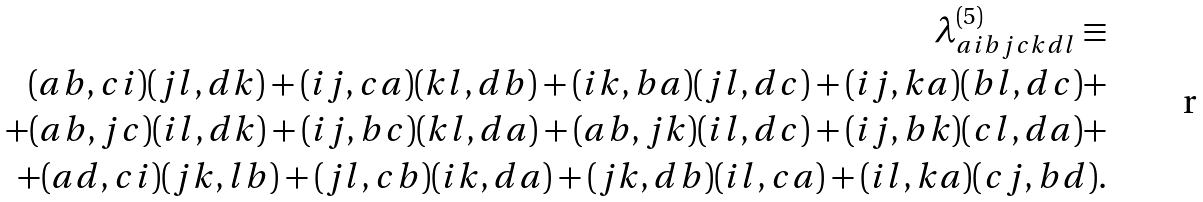<formula> <loc_0><loc_0><loc_500><loc_500>\lambda _ { a i b j c k d l } ^ { ( 5 ) } \equiv \\ ( a b , c i ) ( j l , d k ) + ( i j , c a ) ( k l , d b ) + ( i k , b a ) ( j l , d c ) + ( i j , k a ) ( b l , d c ) + \\ + ( a b , j c ) ( i l , d k ) + ( i j , b c ) ( k l , d a ) + ( a b , j k ) ( i l , d c ) + ( i j , b k ) ( c l , d a ) + \\ + ( a d , c i ) ( j k , l b ) + ( j l , c b ) ( i k , d a ) + ( j k , d b ) ( i l , c a ) + ( i l , k a ) ( c j , b d ) .</formula> 